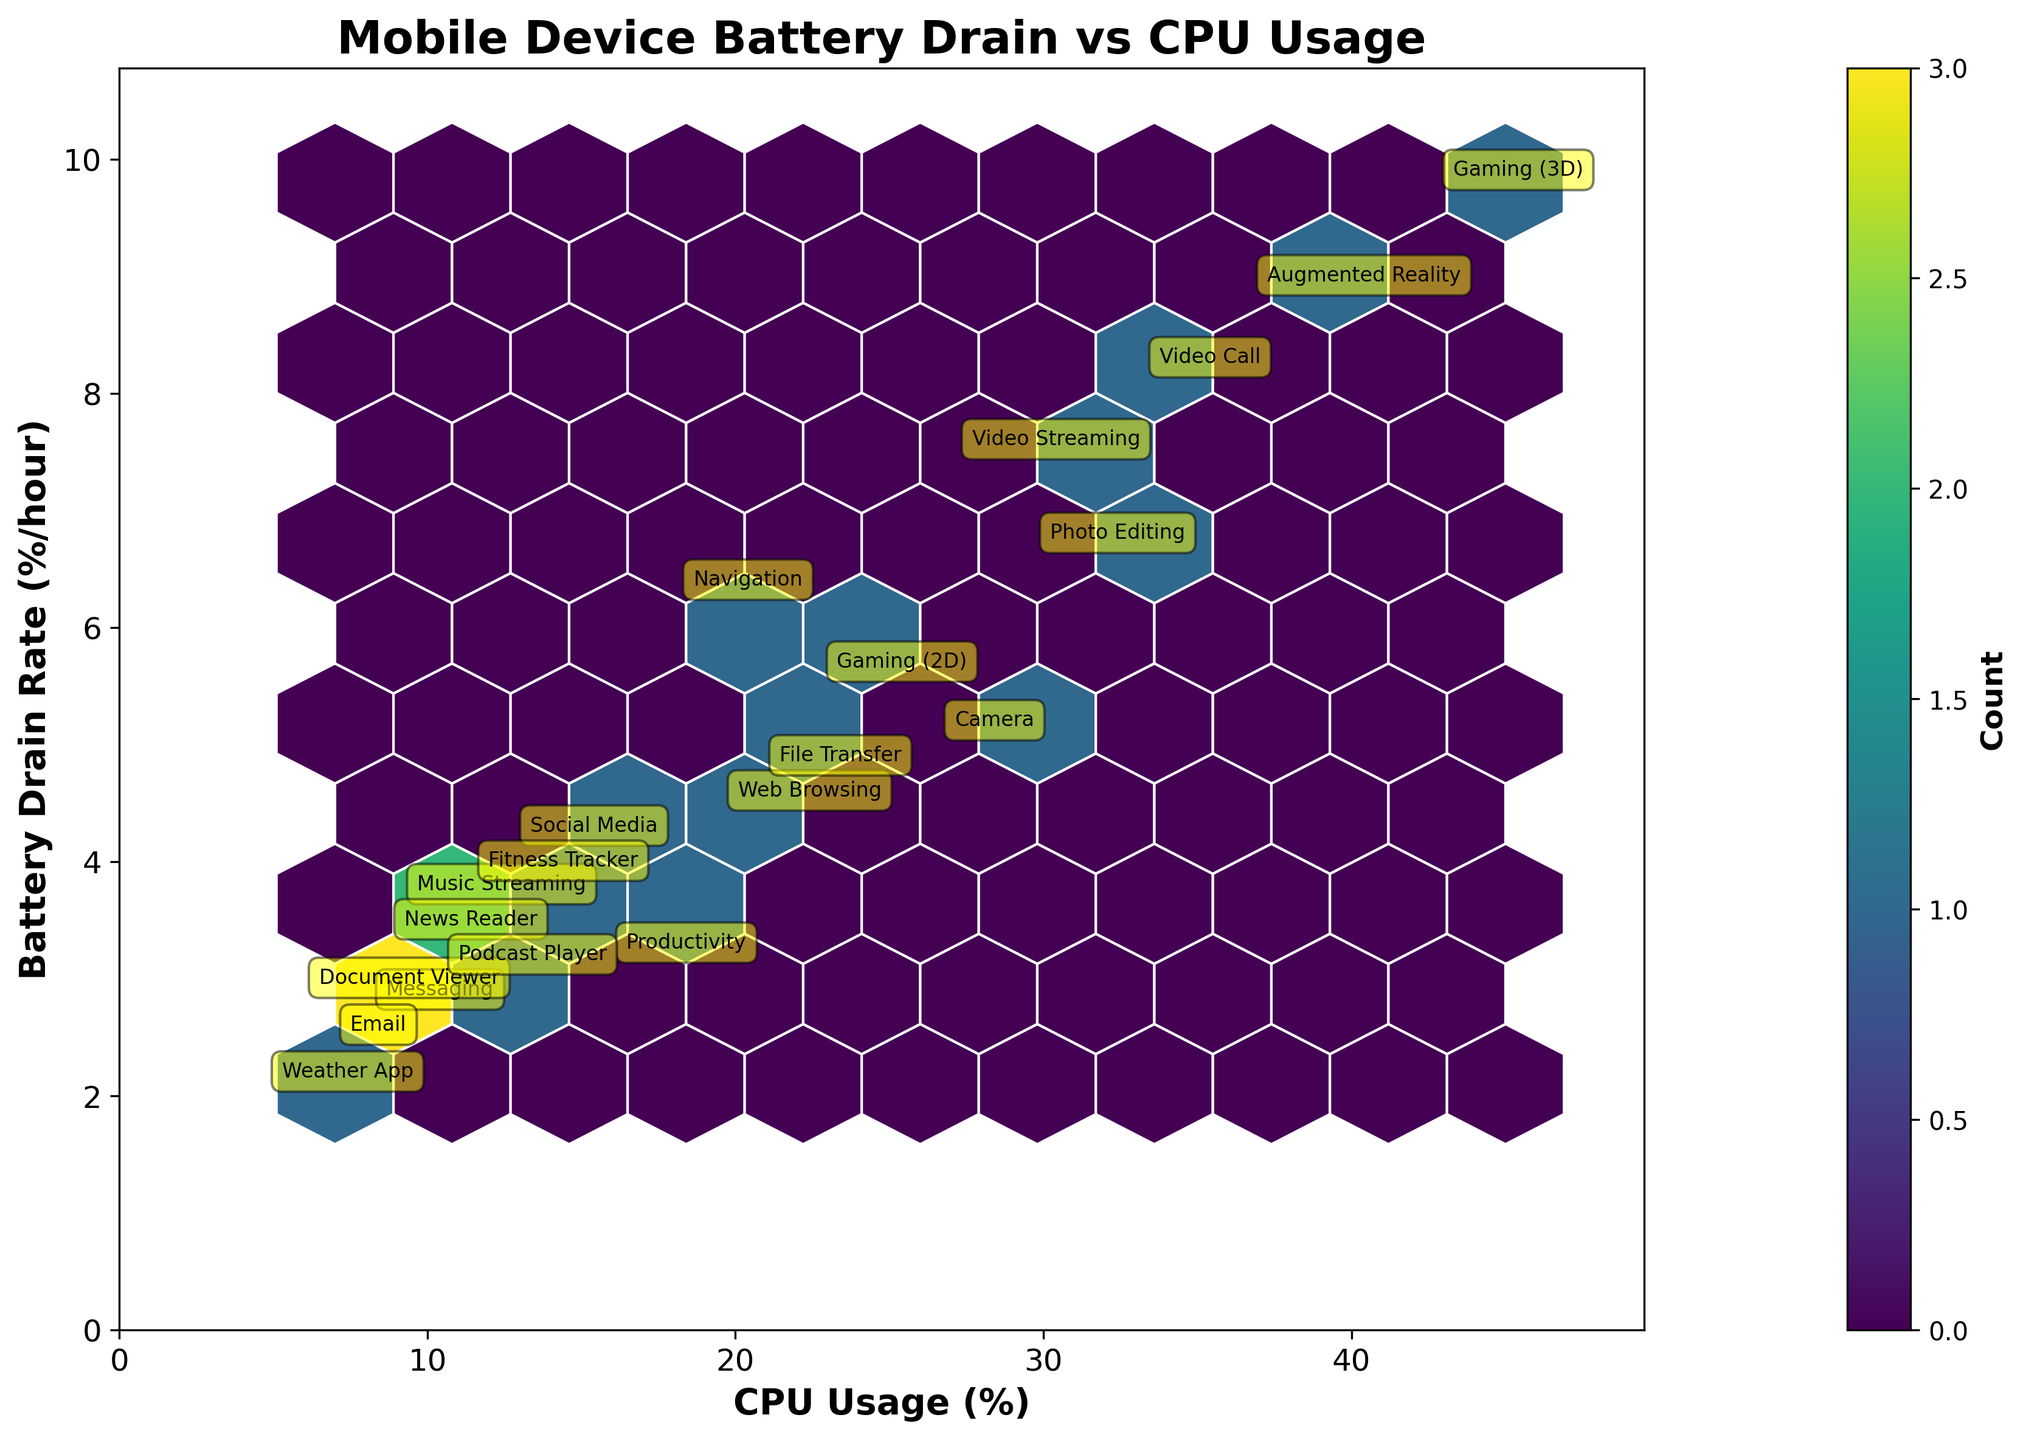what is the title of the plot? The title is located at the top of the plot and usually provides a summary of the information being displayed. The title for this plot is "Mobile Device Battery Drain vs CPU Usage".
Answer: Mobile Device Battery Drain vs CPU Usage Which application type shows the highest CPU usage? To determine this, look at the horizontal axis labels indicating CPU Usage. Find the label with the highest value and identify the application type annotated at that point. 3D Gaming has the highest CPU usage at 45%.
Answer: Gaming (3D) What's the range of battery drain rates displayed in this plot? The range is determined by identifying the minimum and maximum values displayed on the vertical axis for Battery Drain Rate. The lowest is from the Weather App at 2.1 %/hour and the highest is Gaming (3D) at 9.8 %/hour.
Answer: 2.1 - 9.8 %/hour Which application type has the lowest battery drain rate? Look for the lowest labeled point on the Battery Drain Rate axis and find the associated application type. The Weather App has the lowest battery drain rate at 2.1 %/hour.
Answer: Weather App Compare the battery drain rate of Video Streaming and Music Streaming. Which one uses more battery per hour? Find the battery drain rates for both application types on the vertical axis. Video Streaming has 7.5 %/hour, while Music Streaming has 3.7 %/hour, so Video Streaming uses more battery per hour.
Answer: Video Streaming Identify the cluster with the highest data density. What does it indicate? On a hexbin plot, clusters with the highest data density are indicated by the darkest color. This plot uses the 'viridis' color map, where darker shades indicate higher densities. The region around the CPU usage of 10-20% and battery drain rate of 2-4 %/hour is the densest, indicating most apps fall within this range.
Answer: CPU Usage of 10-20% and Battery Drain Rate of 2-4 %/hour What is the difference in CPU usage between Gaming (2D) and Video Streaming? Find the CPU usage values for both applications on the horizontal axis. Gaming (2D) is at 25% and Video Streaming at 30%. The difference is 30% - 25% = 5%.
Answer: 5% What application type has a CPU usage closest to 20%? Scan the horizontal axis for the value closest to 20% and locate the annotated application type. Navigation has a CPU usage closest to 20%.
Answer: Navigation Are there any applications with CPU usage above 40%? Look at the labels on the horizontal axis that are greater than 40%. The only applications above this threshold are Gaming (3D) at 45% and Augmented Reality at 40%.
Answer: Yes, Gaming (3D) and Augmented Reality Which application has a higher battery drain rate: Augmented Reality or Video Call? Find the battery drain rates for both applications on the vertical axis. Augmented Reality has a battery drain rate of 8.9 %/hour, while Video Call has 8.2 %/hour. Thus, Augmented Reality has a higher battery drain rate.
Answer: Augmented Reality 